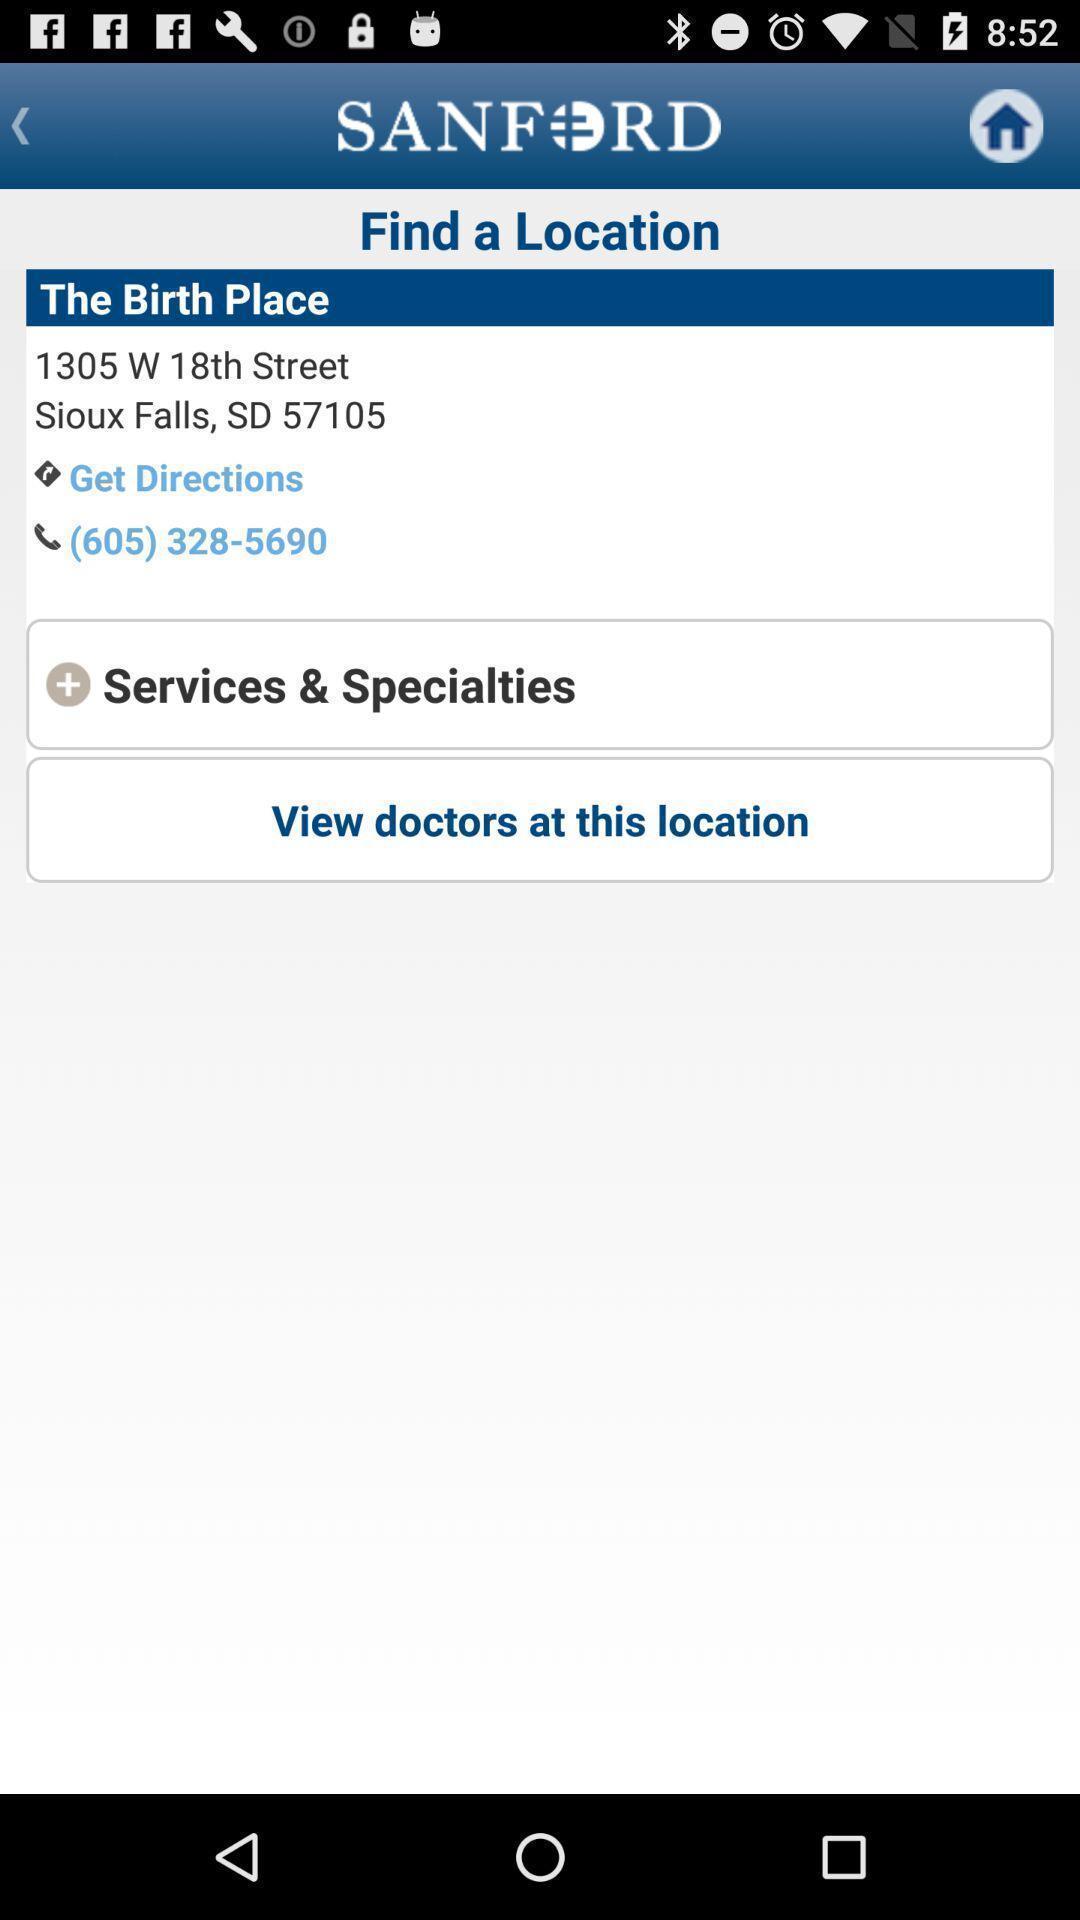Summarize the main components in this picture. Screen displaying birth place location address in health app. 